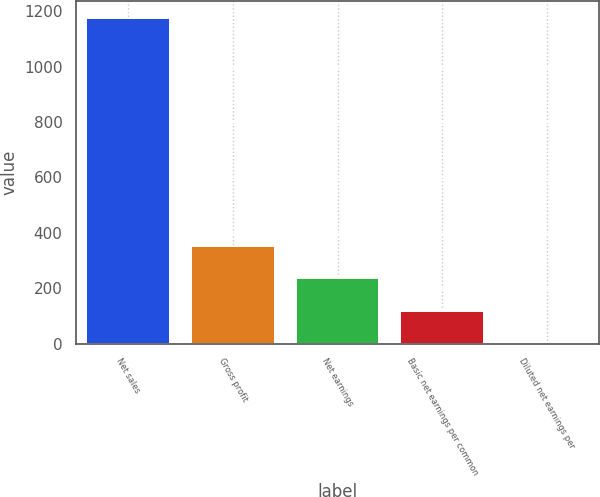Convert chart to OTSL. <chart><loc_0><loc_0><loc_500><loc_500><bar_chart><fcel>Net sales<fcel>Gross profit<fcel>Net earnings<fcel>Basic net earnings per common<fcel>Diluted net earnings per<nl><fcel>1177.4<fcel>353.46<fcel>235.75<fcel>118.04<fcel>0.33<nl></chart> 